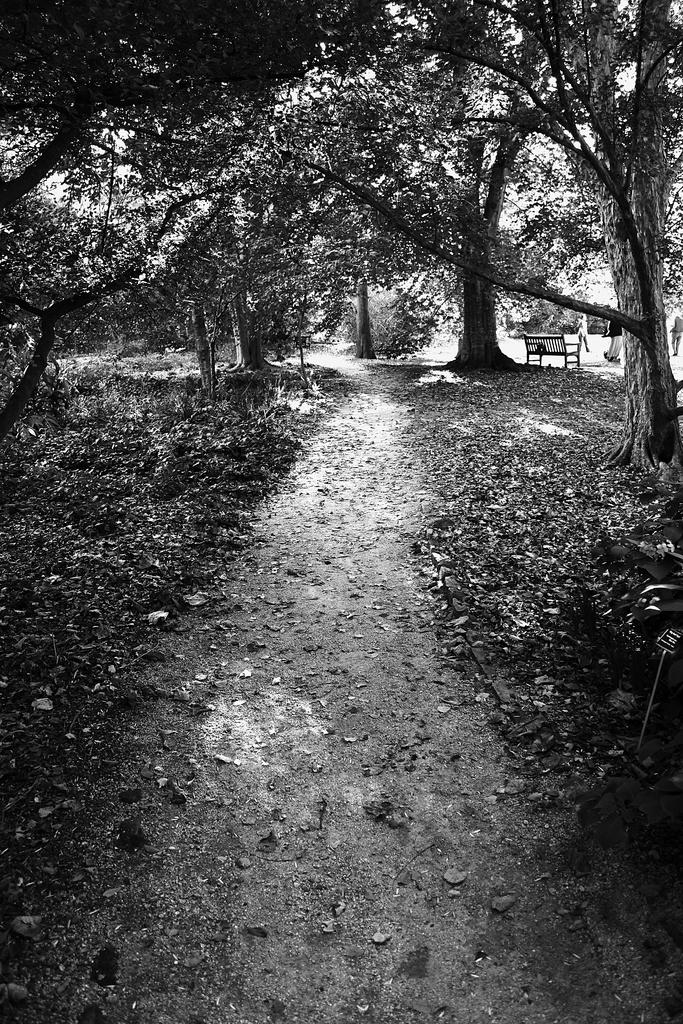What is the color scheme of the image? The image is black and white. What type of natural elements can be seen in the image? There are trees in the image. What is covering the ground in the image? Dry leaves are present on the ground. What type of object can be seen in the background of the image? There is a bench in the background of the image. Can you hear the sound of a zipper in the image? There is no sound present in the image, and therefore no zipper sound can be heard. 